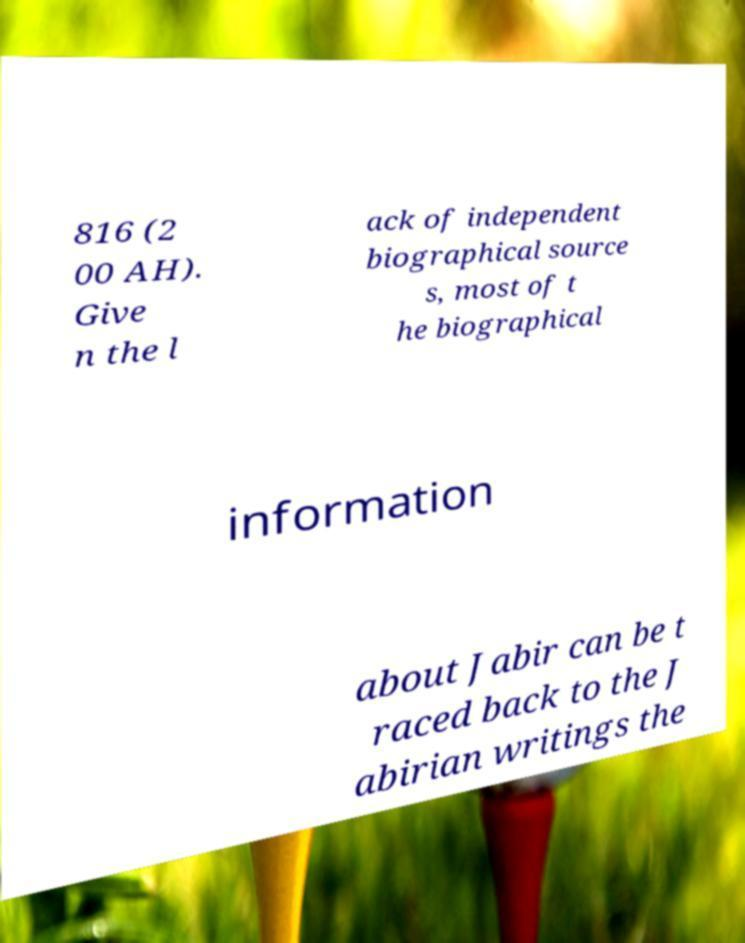What messages or text are displayed in this image? I need them in a readable, typed format. 816 (2 00 AH). Give n the l ack of independent biographical source s, most of t he biographical information about Jabir can be t raced back to the J abirian writings the 